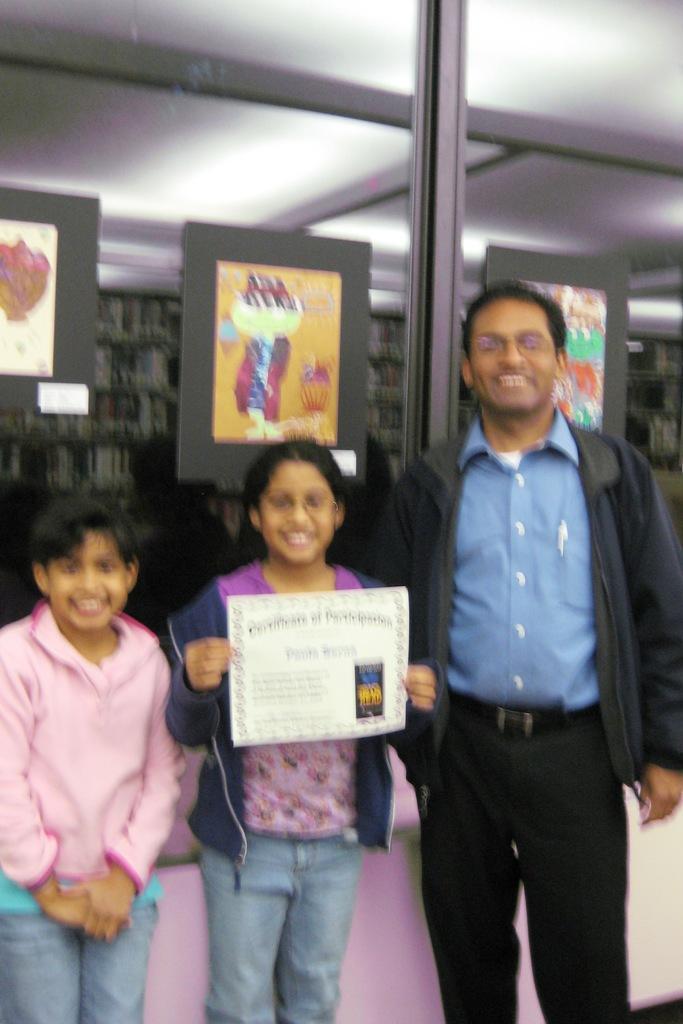Can you describe this image briefly? In this image, we can see a man and two children are standing and they are smiling and one of them is holding a paper. In the background, we can see some posters. 